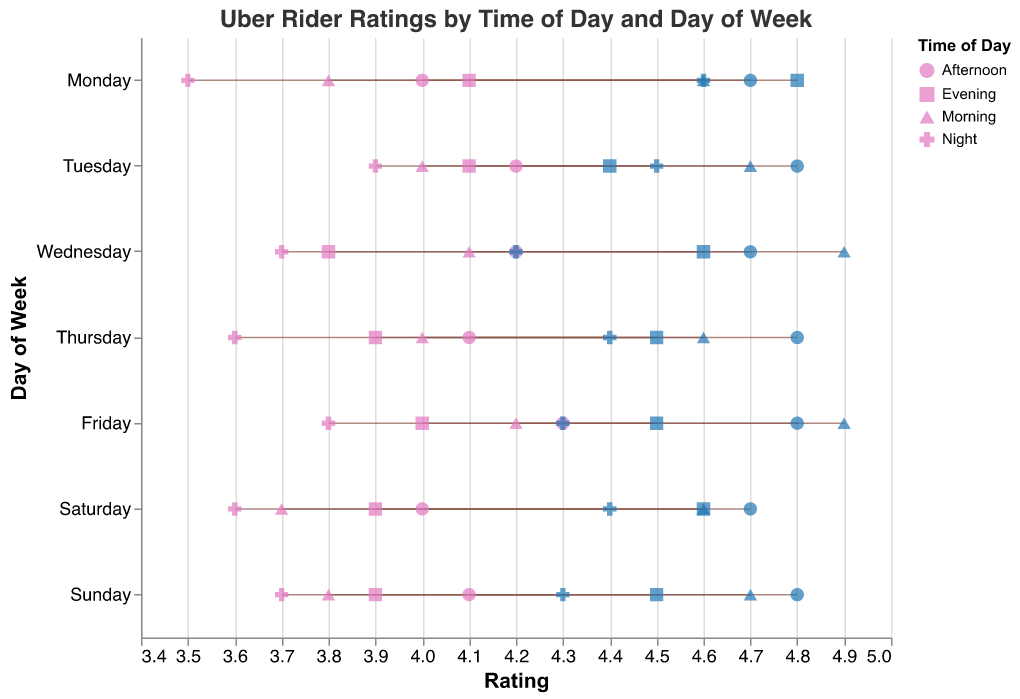What is the title of the plot? The title is displayed at the top of the plot in a larger font size, making it easy to identify the primary subject of the visual.
Answer: Uber Rider Ratings by Time of Day and Day of Week Which day and time of day has the widest range of ratings? By visually inspecting the horizontal lines' length for each day and time combination, we can determine the widest range. Wednesday Morning has the longest horizontal line going from 4.1 to 4.9, making it the widest range.
Answer: Wednesday Morning What is the lowest rating observed in the dataset? The lowest rating, represented by the smallest minimum rating dot, can be seen at Monday Night, which is 3.5.
Answer: 3.5 How does the maximum rating for Thursday Afternoon compare to that of Saturday Afternoon? By comparing the maximum rating points in their respective rows, it is observed that both Thursday Afternoon and Saturday Afternoon have a maximum rating of 4.8.
Answer: Equal Which time of day generally shows the lowest minimum ratings across the week? Observing the minimum rating points, the time of day with the most frequent lowest minimum ratings is the Night, where the ratings are lower every night compared to other time periods.
Answer: Night What is the average of the minimum ratings for Friday? The minimum ratings for Friday at different times are 4.2, 4.3, 4.0, and 3.8. Summing these values and then dividing by 4 results in the average minimum rating: (4.2 + 4.3 + 4.0 + 3.8)/4 = 4.075.
Answer: 4.075 What is the difference between the maximum and minimum ratings for Tuesday Evening? The minimum and maximum ratings for Tuesday Evening are 4.1 and 4.4, respectively. The difference is calculated as 4.4 - 4.1 = 0.3.
Answer: 0.3 Which days have mornings with a maximum rating of 4.6? Inspecting the maximum rating dots labeled for 'Morning,' it is observed that Monday, Thursday, and Saturday each have a maximum rating of 4.6 in the morning.
Answer: Monday, Thursday, Saturday Is the maximum rating for Sunday Evening higher than that for Saturday Evening? Comparing the maximum rating points for Sunday Evening (4.5) and Saturday Evening (4.6), it's observed that Saturday Evening has a higher maximum rating.
Answer: No What trend is visible in rider ratings from morning to night on Friday? By following the dots and lines for each time slot on Friday, the trend is noticeable: the ratings start high in the morning (4.2 to 4.9), slightly drop in the afternoon (4.3 to 4.8), then descend further in the evening (4.0 to 4.5), and reach a lower point at night (3.8 to 4.3).
Answer: Decline 